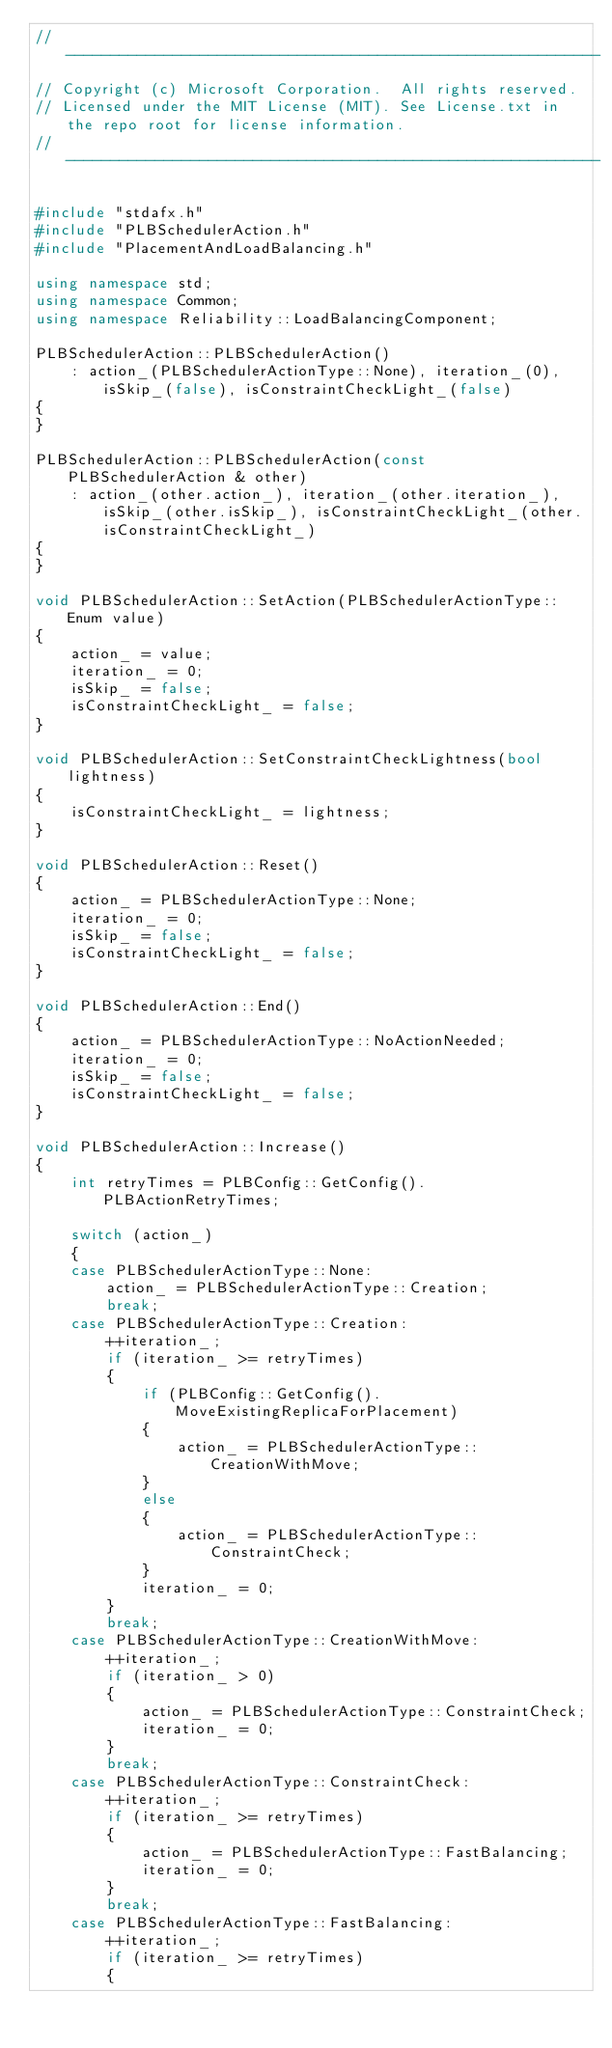Convert code to text. <code><loc_0><loc_0><loc_500><loc_500><_C++_>// ------------------------------------------------------------
// Copyright (c) Microsoft Corporation.  All rights reserved.
// Licensed under the MIT License (MIT). See License.txt in the repo root for license information.
// ------------------------------------------------------------

#include "stdafx.h"
#include "PLBSchedulerAction.h"
#include "PlacementAndLoadBalancing.h"

using namespace std;
using namespace Common;
using namespace Reliability::LoadBalancingComponent;

PLBSchedulerAction::PLBSchedulerAction()
    : action_(PLBSchedulerActionType::None), iteration_(0), isSkip_(false), isConstraintCheckLight_(false)
{
}

PLBSchedulerAction::PLBSchedulerAction(const PLBSchedulerAction & other)
    : action_(other.action_), iteration_(other.iteration_), isSkip_(other.isSkip_), isConstraintCheckLight_(other.isConstraintCheckLight_)
{
}

void PLBSchedulerAction::SetAction(PLBSchedulerActionType::Enum value)
{
    action_ = value;
    iteration_ = 0;
    isSkip_ = false;
    isConstraintCheckLight_ = false;
}

void PLBSchedulerAction::SetConstraintCheckLightness(bool lightness)
{
    isConstraintCheckLight_ = lightness;
}

void PLBSchedulerAction::Reset()
{
    action_ = PLBSchedulerActionType::None;
    iteration_ = 0;
    isSkip_ = false;
    isConstraintCheckLight_ = false;
}

void PLBSchedulerAction::End()
{
    action_ = PLBSchedulerActionType::NoActionNeeded;
    iteration_ = 0;
    isSkip_ = false;
    isConstraintCheckLight_ = false;
}

void PLBSchedulerAction::Increase()
{
    int retryTimes = PLBConfig::GetConfig().PLBActionRetryTimes;

    switch (action_)
    {
    case PLBSchedulerActionType::None:
        action_ = PLBSchedulerActionType::Creation;
        break;
    case PLBSchedulerActionType::Creation:
        ++iteration_;
        if (iteration_ >= retryTimes)
        {
            if (PLBConfig::GetConfig().MoveExistingReplicaForPlacement)
            {
                action_ = PLBSchedulerActionType::CreationWithMove;
            }
            else
            {
                action_ = PLBSchedulerActionType::ConstraintCheck;
            }
            iteration_ = 0;
        }
        break;
    case PLBSchedulerActionType::CreationWithMove:
        ++iteration_;
        if (iteration_ > 0)
        {
            action_ = PLBSchedulerActionType::ConstraintCheck;
            iteration_ = 0;
        }
        break;
    case PLBSchedulerActionType::ConstraintCheck:
        ++iteration_;
        if (iteration_ >= retryTimes)
        {
            action_ = PLBSchedulerActionType::FastBalancing;
            iteration_ = 0;
        }
        break;
    case PLBSchedulerActionType::FastBalancing:
        ++iteration_;
        if (iteration_ >= retryTimes)
        {</code> 